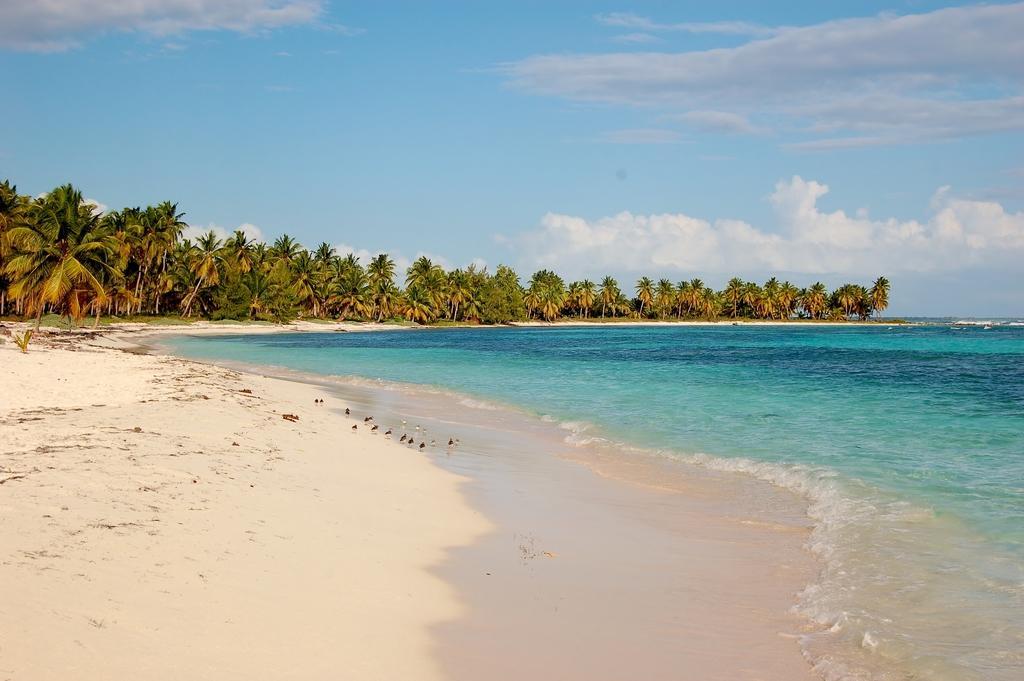Please provide a concise description of this image. In this image I can see in the middle there are trees, on the right side it is the sea. At the top it is the cloudy sky. 